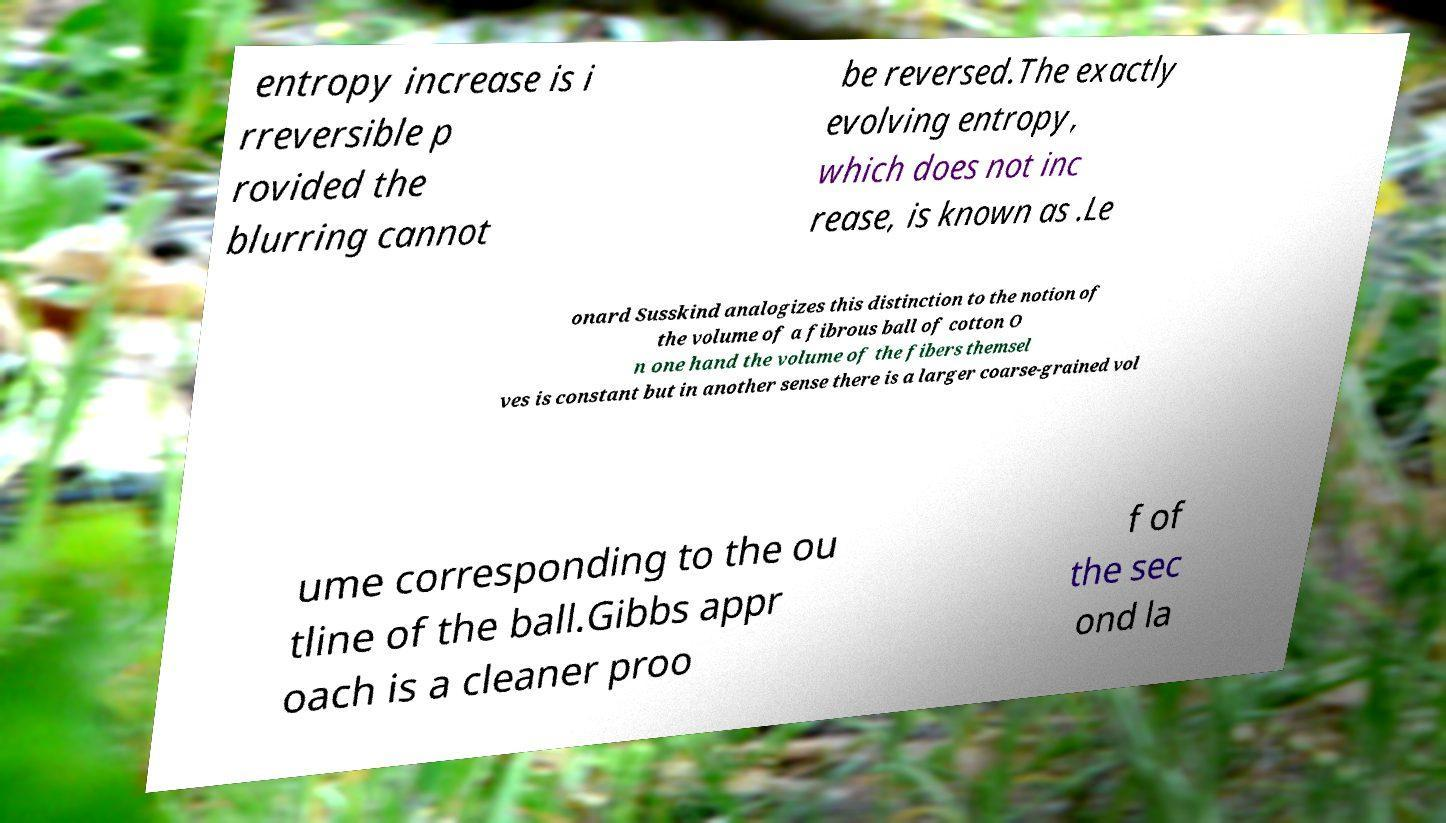Could you assist in decoding the text presented in this image and type it out clearly? entropy increase is i rreversible p rovided the blurring cannot be reversed.The exactly evolving entropy, which does not inc rease, is known as .Le onard Susskind analogizes this distinction to the notion of the volume of a fibrous ball of cotton O n one hand the volume of the fibers themsel ves is constant but in another sense there is a larger coarse-grained vol ume corresponding to the ou tline of the ball.Gibbs appr oach is a cleaner proo f of the sec ond la 